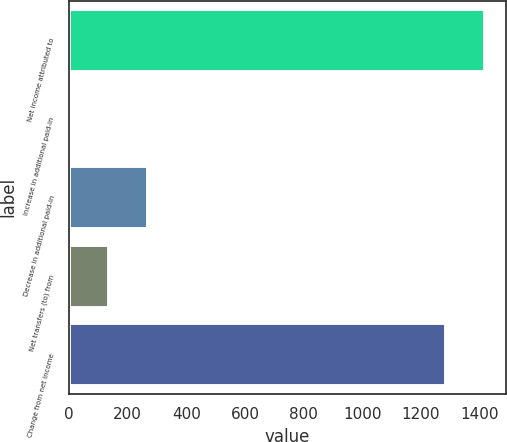Convert chart to OTSL. <chart><loc_0><loc_0><loc_500><loc_500><bar_chart><fcel>Net income attributed to<fcel>Increase in additional paid-in<fcel>Decrease in additional paid-in<fcel>Net transfers (to) from<fcel>Change from net income<nl><fcel>1418.9<fcel>4.4<fcel>268.8<fcel>136.6<fcel>1286.7<nl></chart> 